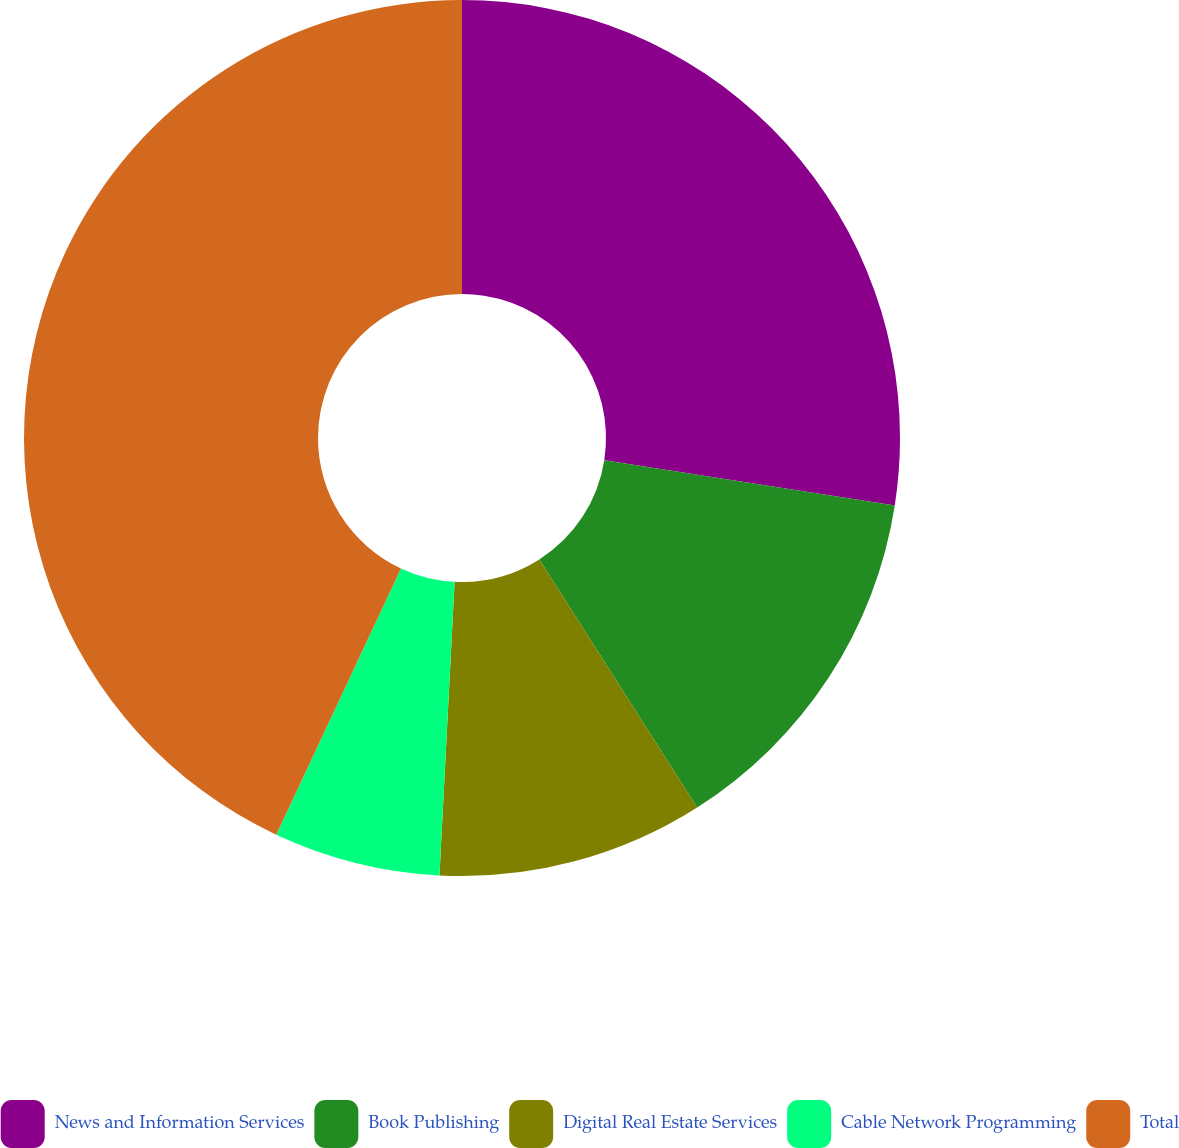<chart> <loc_0><loc_0><loc_500><loc_500><pie_chart><fcel>News and Information Services<fcel>Book Publishing<fcel>Digital Real Estate Services<fcel>Cable Network Programming<fcel>Total<nl><fcel>27.46%<fcel>13.52%<fcel>9.84%<fcel>6.15%<fcel>43.03%<nl></chart> 